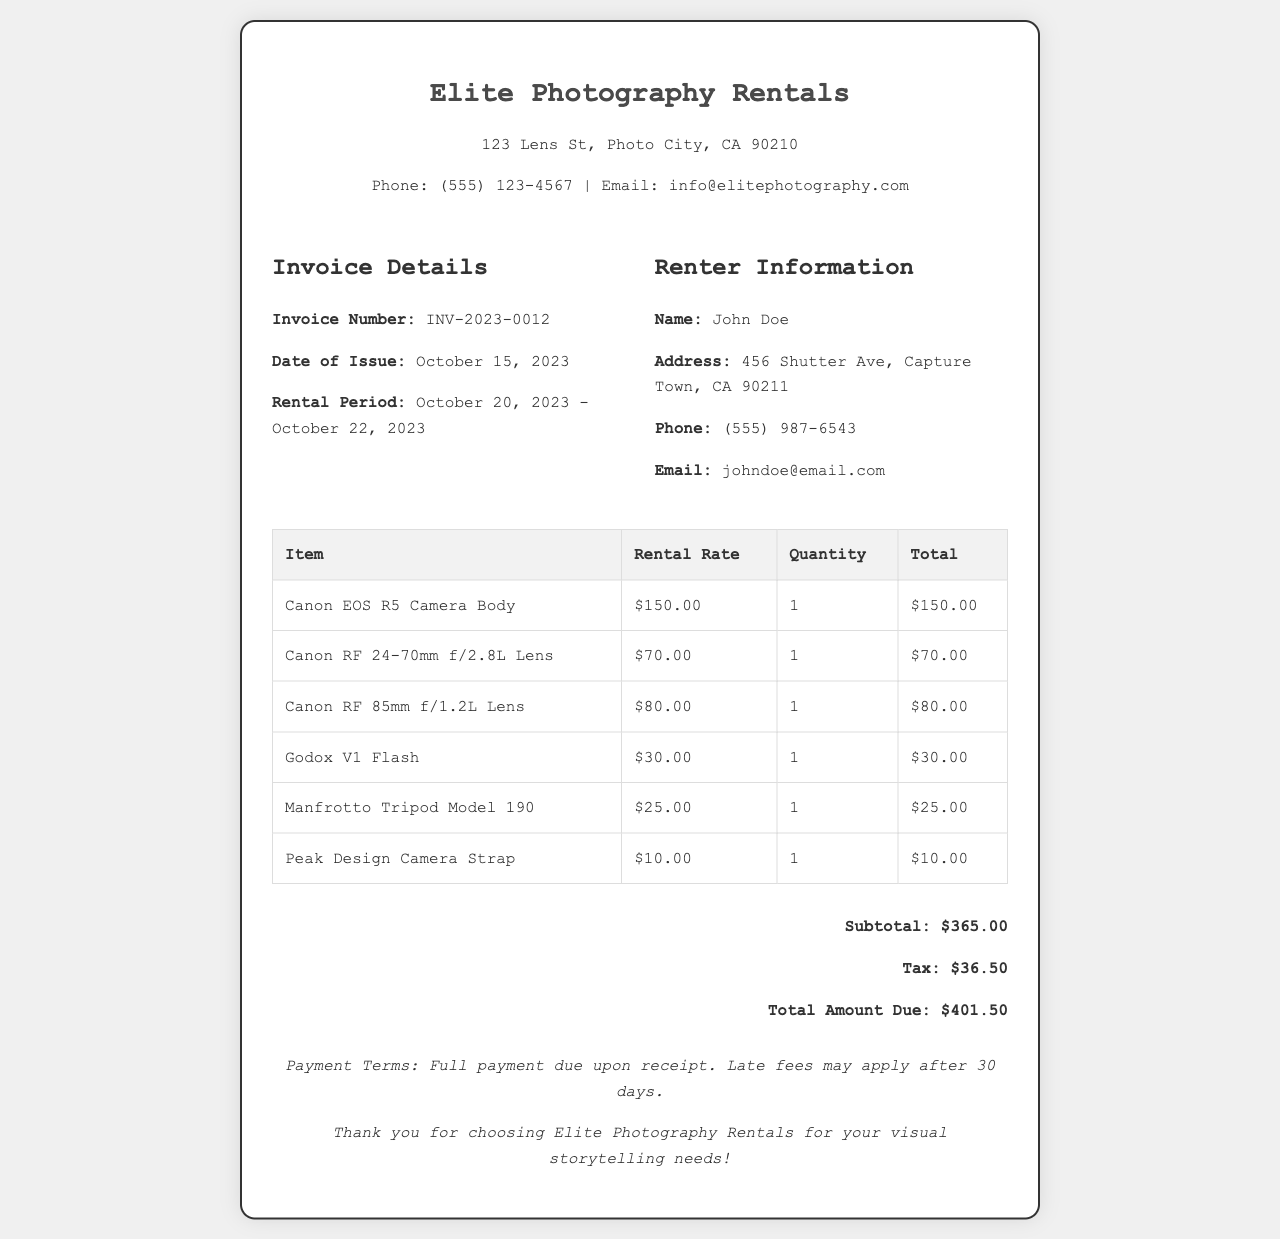What is the invoice number? The invoice number is clearly labeled as "Invoice Number" in the document.
Answer: INV-2023-0012 Who rented the equipment? The renter's name is listed under "Renter Information" in the document.
Answer: John Doe What is the total amount due? The total amount due is specified in the document under "Total Amount Due."
Answer: $401.50 What is the rental period? The rental period spans from October 20, 2023, to October 22, 2023, mentioned in the details section.
Answer: October 20, 2023 - October 22, 2023 How much was charged for the Canon EOS R5 Camera Body? The rental rate for the Canon EOS R5 Camera Body is provided in the invoice.
Answer: $150.00 What is the subtotal before tax? The subtotal is stated in the total section of the document, representing the total before tax is applied.
Answer: $365.00 How many lenses were rented? The document lists the lens items, and counting them will indicate the total number of lenses rented.
Answer: 2 What is the tax amount? The tax amount is explicitly mentioned in the total section of the invoice.
Answer: $36.50 What company issued the invoice? The company name is at the top of the invoice in the header section.
Answer: Elite Photography Rentals 